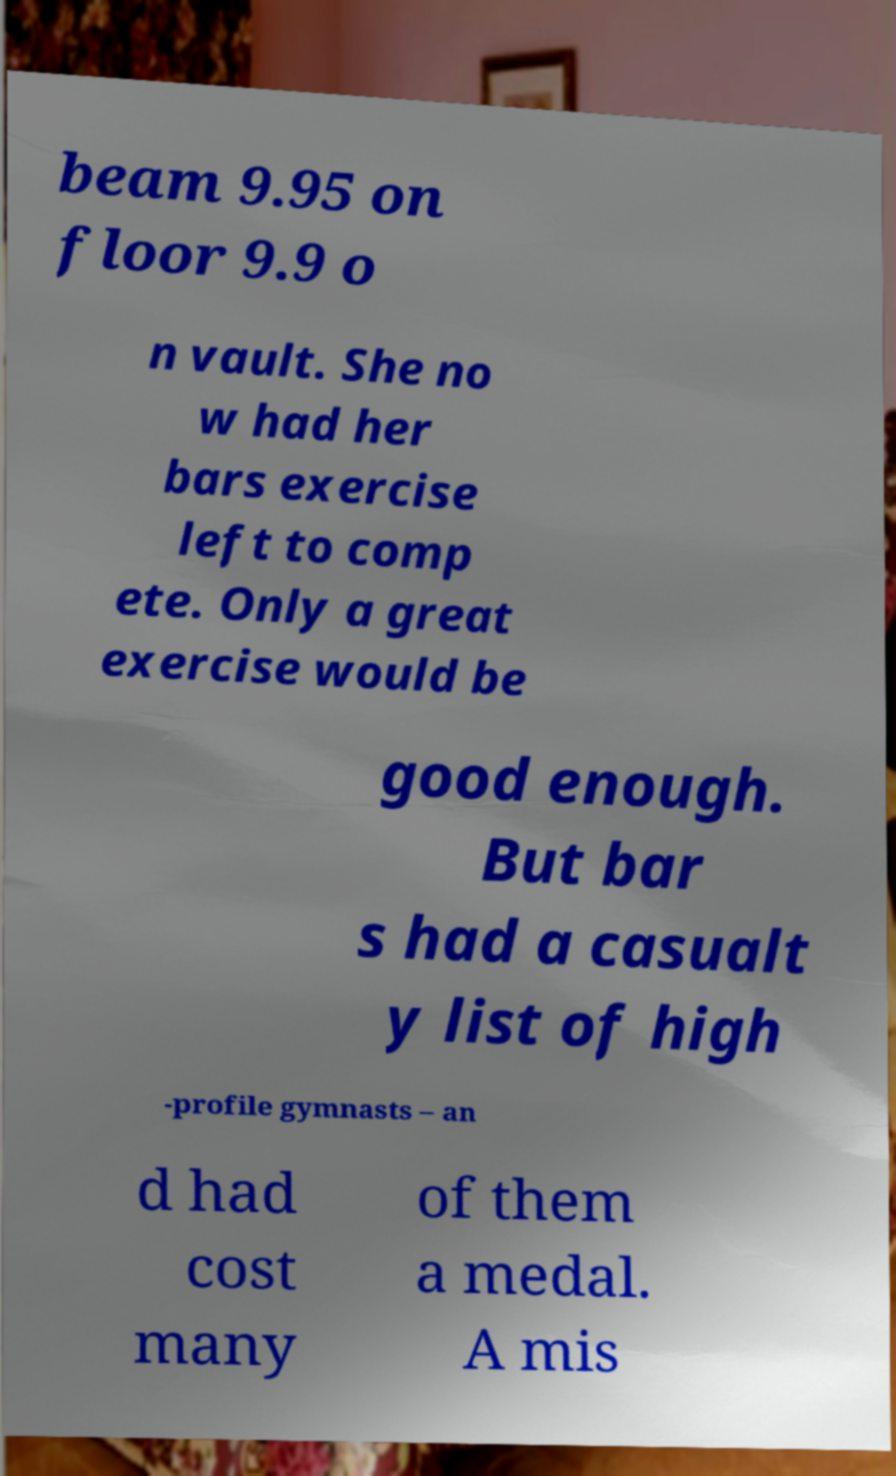Could you assist in decoding the text presented in this image and type it out clearly? beam 9.95 on floor 9.9 o n vault. She no w had her bars exercise left to comp ete. Only a great exercise would be good enough. But bar s had a casualt y list of high -profile gymnasts – an d had cost many of them a medal. A mis 